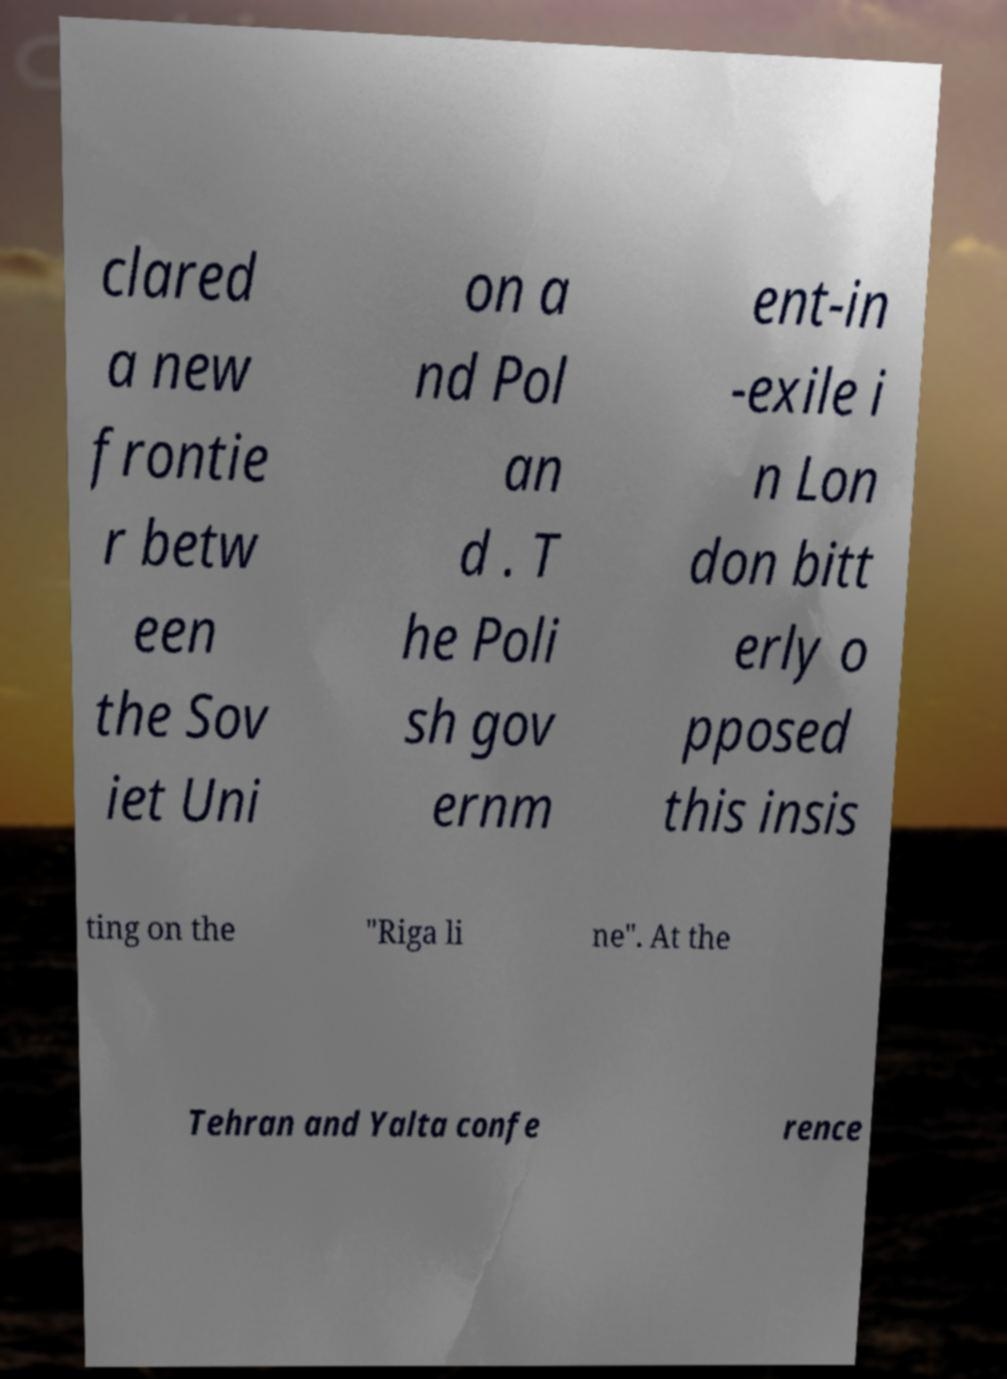There's text embedded in this image that I need extracted. Can you transcribe it verbatim? clared a new frontie r betw een the Sov iet Uni on a nd Pol an d . T he Poli sh gov ernm ent-in -exile i n Lon don bitt erly o pposed this insis ting on the "Riga li ne". At the Tehran and Yalta confe rence 